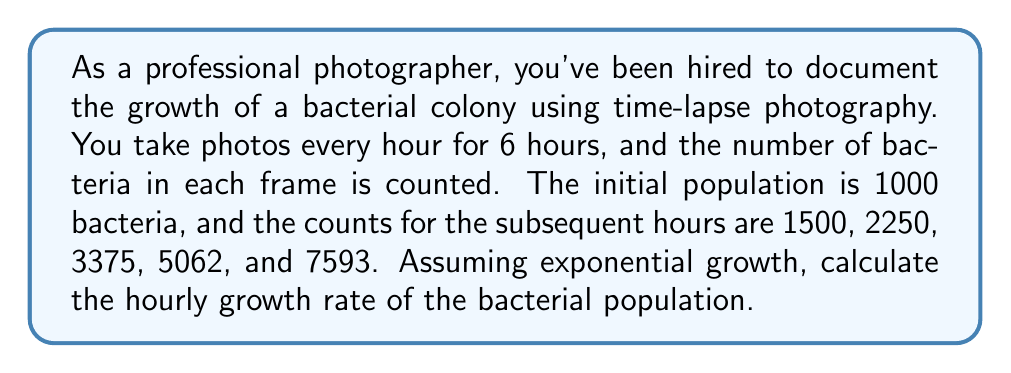What is the answer to this math problem? To solve this problem, we'll use the exponential growth model and the given data to calculate the hourly growth rate.

The exponential growth model is given by:

$$N(t) = N_0 e^{rt}$$

Where:
$N(t)$ is the population at time $t$
$N_0$ is the initial population
$r$ is the growth rate
$t$ is the time

We can calculate the growth rate using any two data points. Let's use the initial population and the final population after 6 hours.

$N_0 = 1000$
$N(6) = 7593$
$t = 6$ hours

Substituting these values into the exponential growth equation:

$$7593 = 1000 e^{6r}$$

Dividing both sides by 1000:

$$7.593 = e^{6r}$$

Taking the natural logarithm of both sides:

$$\ln(7.593) = 6r$$

Solving for $r$:

$$r = \frac{\ln(7.593)}{6}$$

$$r = \frac{2.0271}{6} \approx 0.3378$$

To verify, we can calculate the population at each hour using this growth rate:

Hour 1: $1000 e^{0.3378 \cdot 1} \approx 1402$
Hour 2: $1000 e^{0.3378 \cdot 2} \approx 1965$
Hour 3: $1000 e^{0.3378 \cdot 3} \approx 2755$
Hour 4: $1000 e^{0.3378 \cdot 4} \approx 3862$
Hour 5: $1000 e^{0.3378 \cdot 5} \approx 5413$
Hour 6: $1000 e^{0.3378 \cdot 6} \approx 7593$

These values are close to the observed counts, confirming our calculation.
Answer: The hourly growth rate of the bacterial population is approximately 0.3378 or 33.78%. 